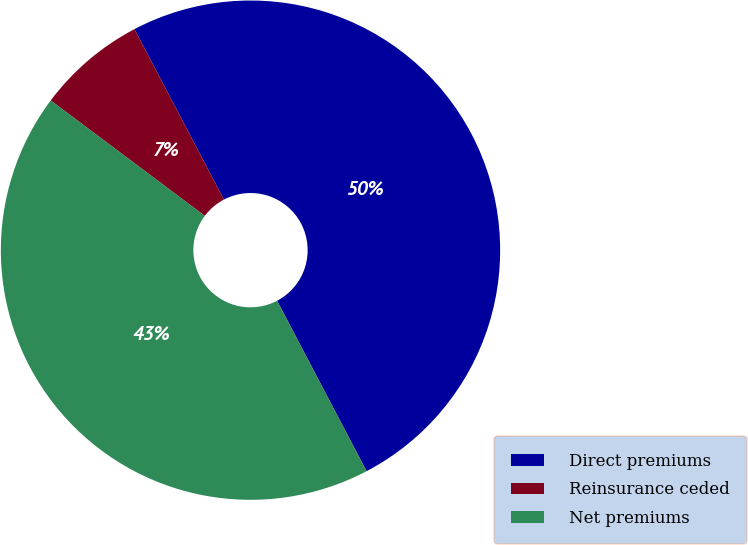Convert chart. <chart><loc_0><loc_0><loc_500><loc_500><pie_chart><fcel>Direct premiums<fcel>Reinsurance ceded<fcel>Net premiums<nl><fcel>50.0%<fcel>7.07%<fcel>42.93%<nl></chart> 